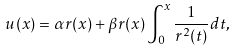Convert formula to latex. <formula><loc_0><loc_0><loc_500><loc_500>u ( x ) = \alpha r ( x ) + \beta r ( x ) \int _ { 0 } ^ { x } \frac { 1 } { r ^ { 2 } ( t ) } d t ,</formula> 